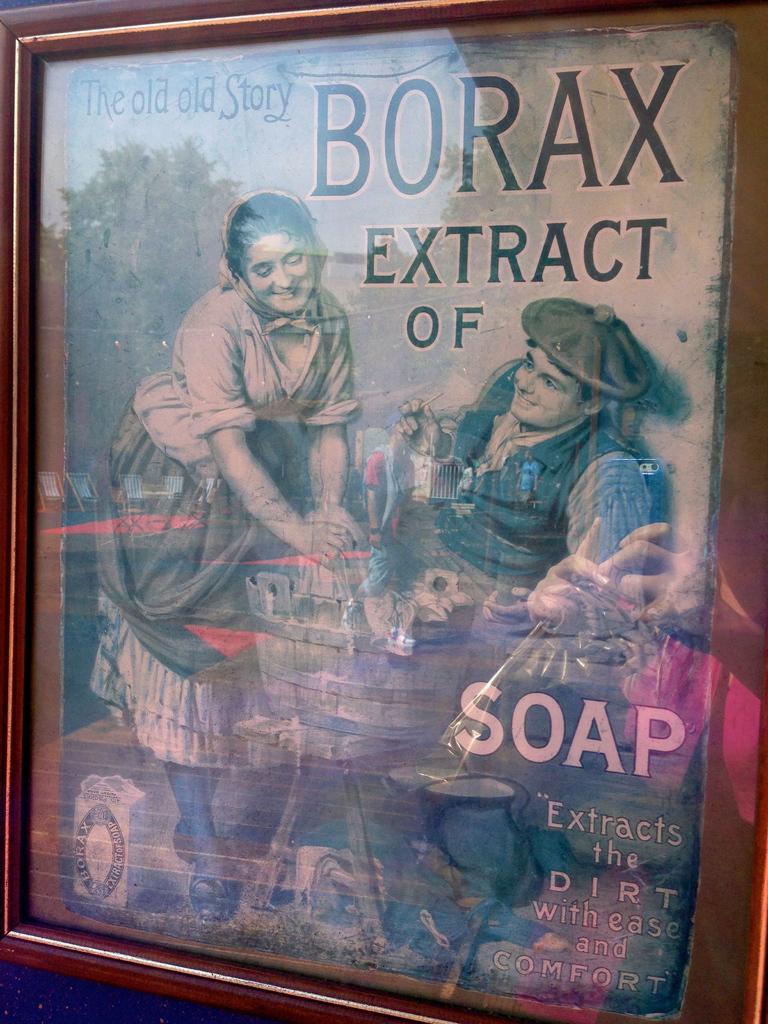What is the old poster trying to sell?
Your answer should be very brief. Soap. What is the brand being advertised?
Give a very brief answer. Borax. 